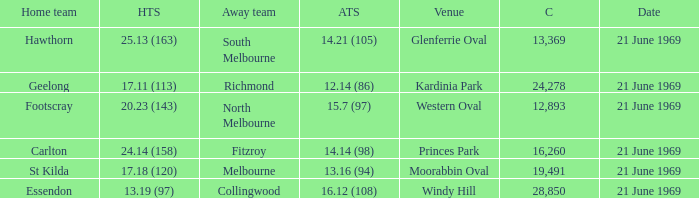When was there a game at Kardinia Park? 21 June 1969. 